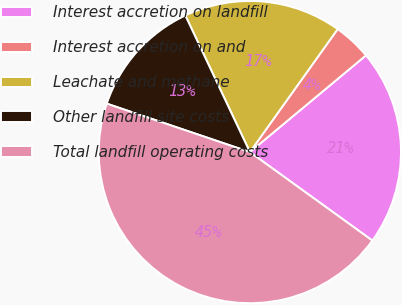Convert chart. <chart><loc_0><loc_0><loc_500><loc_500><pie_chart><fcel>Interest accretion on landfill<fcel>Interest accretion on and<fcel>Leachate and methane<fcel>Other landfill site costs<fcel>Total landfill operating costs<nl><fcel>21.01%<fcel>4.08%<fcel>16.89%<fcel>12.78%<fcel>45.24%<nl></chart> 